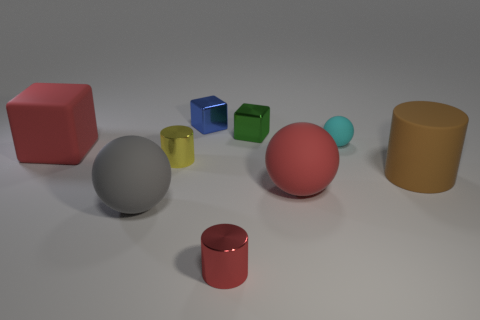Is the size of the red metal thing the same as the metallic cylinder that is behind the gray object?
Ensure brevity in your answer.  Yes. What is the size of the metal cylinder behind the cylinder that is to the right of the tiny rubber thing behind the brown cylinder?
Provide a succinct answer. Small. Is there a big brown rubber cylinder?
Provide a succinct answer. Yes. There is a tiny thing that is the same color as the rubber block; what material is it?
Keep it short and to the point. Metal. How many cylinders are the same color as the small matte thing?
Provide a short and direct response. 0. How many things are metal blocks that are on the right side of the red metal cylinder or objects right of the small blue object?
Provide a succinct answer. 5. There is a large red rubber object behind the big brown rubber object; how many large gray matte balls are in front of it?
Keep it short and to the point. 1. The large cylinder that is the same material as the red ball is what color?
Provide a succinct answer. Brown. Are there any balls that have the same size as the red matte block?
Offer a very short reply. Yes. There is a gray thing that is the same size as the brown cylinder; what is its shape?
Provide a succinct answer. Sphere. 